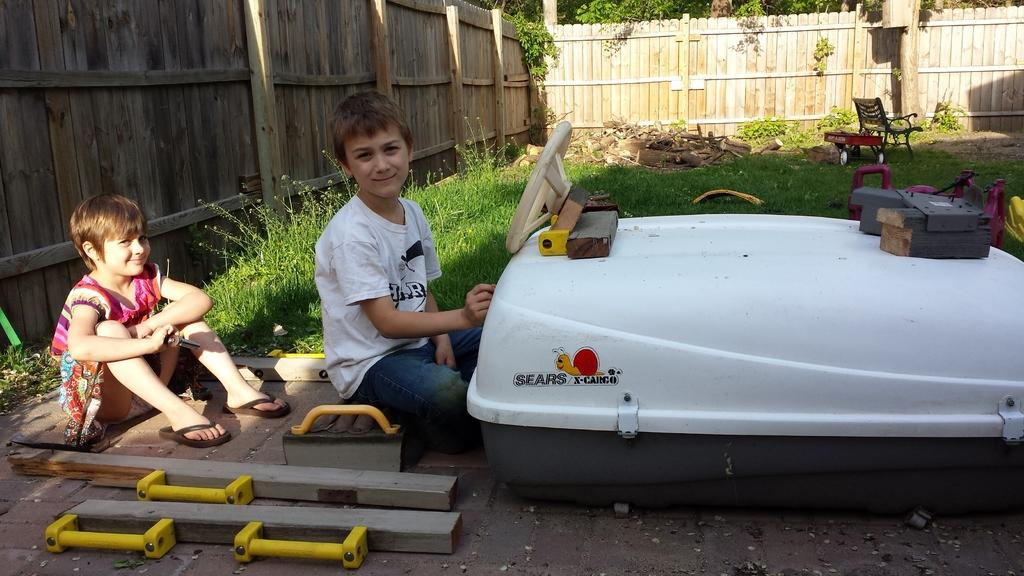How many people are in the image? There are two people in the image, a girl and a boy. What are the girl and boy doing in the image? The girl and boy are sitting. What can be seen in the background of the image? In the background, there is a fence, grass, trees, a cart, a chair, and plants. What type of belief can be seen in the image? There is no belief present in the image; it features a girl and a boy sitting with various objects and elements in the background. How does the chair breathe in the image? The chair does not breathe in the image; it is an inanimate object. 